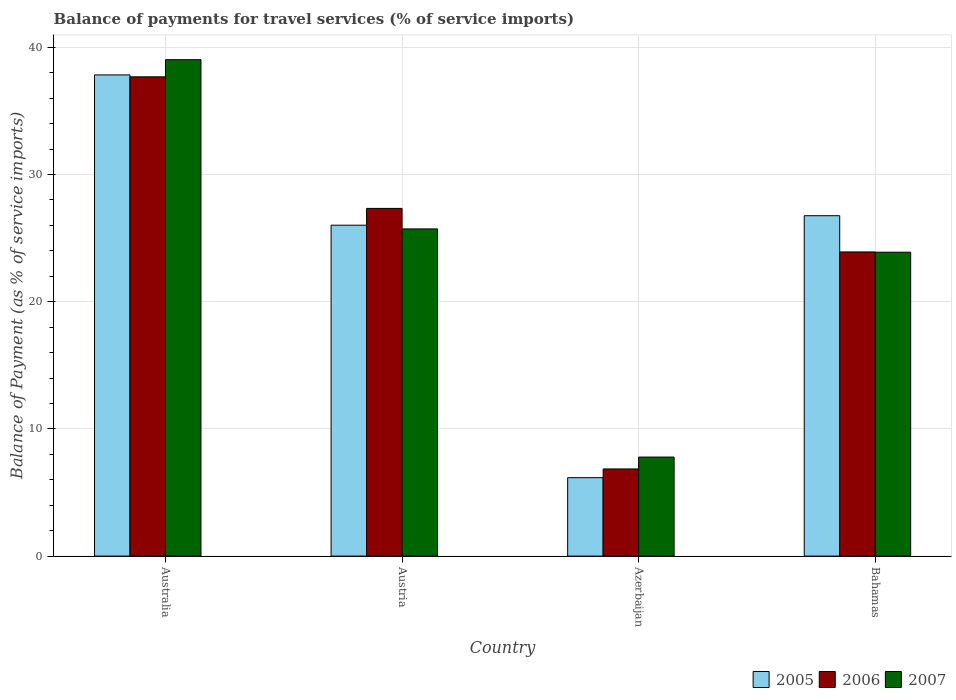How many different coloured bars are there?
Your answer should be compact. 3. How many groups of bars are there?
Offer a very short reply. 4. Are the number of bars per tick equal to the number of legend labels?
Your answer should be very brief. Yes. Are the number of bars on each tick of the X-axis equal?
Your answer should be very brief. Yes. How many bars are there on the 3rd tick from the left?
Provide a short and direct response. 3. What is the label of the 4th group of bars from the left?
Your answer should be compact. Bahamas. What is the balance of payments for travel services in 2006 in Bahamas?
Give a very brief answer. 23.92. Across all countries, what is the maximum balance of payments for travel services in 2007?
Make the answer very short. 39.03. Across all countries, what is the minimum balance of payments for travel services in 2007?
Your response must be concise. 7.79. In which country was the balance of payments for travel services in 2005 maximum?
Your answer should be compact. Australia. In which country was the balance of payments for travel services in 2005 minimum?
Offer a very short reply. Azerbaijan. What is the total balance of payments for travel services in 2007 in the graph?
Make the answer very short. 96.44. What is the difference between the balance of payments for travel services in 2006 in Australia and that in Bahamas?
Keep it short and to the point. 13.77. What is the difference between the balance of payments for travel services in 2007 in Austria and the balance of payments for travel services in 2005 in Bahamas?
Your response must be concise. -1.04. What is the average balance of payments for travel services in 2006 per country?
Ensure brevity in your answer.  23.95. What is the difference between the balance of payments for travel services of/in 2006 and balance of payments for travel services of/in 2007 in Australia?
Your response must be concise. -1.35. What is the ratio of the balance of payments for travel services in 2005 in Australia to that in Austria?
Offer a very short reply. 1.45. What is the difference between the highest and the second highest balance of payments for travel services in 2005?
Offer a very short reply. 0.75. What is the difference between the highest and the lowest balance of payments for travel services in 2005?
Your answer should be very brief. 31.67. In how many countries, is the balance of payments for travel services in 2006 greater than the average balance of payments for travel services in 2006 taken over all countries?
Give a very brief answer. 2. What does the 3rd bar from the left in Bahamas represents?
Offer a terse response. 2007. What does the 3rd bar from the right in Australia represents?
Keep it short and to the point. 2005. Is it the case that in every country, the sum of the balance of payments for travel services in 2007 and balance of payments for travel services in 2005 is greater than the balance of payments for travel services in 2006?
Your response must be concise. Yes. How many countries are there in the graph?
Offer a terse response. 4. Are the values on the major ticks of Y-axis written in scientific E-notation?
Make the answer very short. No. Does the graph contain any zero values?
Your answer should be compact. No. Where does the legend appear in the graph?
Your response must be concise. Bottom right. How many legend labels are there?
Your answer should be very brief. 3. How are the legend labels stacked?
Give a very brief answer. Horizontal. What is the title of the graph?
Give a very brief answer. Balance of payments for travel services (% of service imports). Does "2004" appear as one of the legend labels in the graph?
Offer a terse response. No. What is the label or title of the Y-axis?
Make the answer very short. Balance of Payment (as % of service imports). What is the Balance of Payment (as % of service imports) in 2005 in Australia?
Give a very brief answer. 37.83. What is the Balance of Payment (as % of service imports) in 2006 in Australia?
Offer a very short reply. 37.68. What is the Balance of Payment (as % of service imports) in 2007 in Australia?
Ensure brevity in your answer.  39.03. What is the Balance of Payment (as % of service imports) of 2005 in Austria?
Provide a short and direct response. 26.02. What is the Balance of Payment (as % of service imports) in 2006 in Austria?
Keep it short and to the point. 27.34. What is the Balance of Payment (as % of service imports) of 2007 in Austria?
Give a very brief answer. 25.73. What is the Balance of Payment (as % of service imports) in 2005 in Azerbaijan?
Provide a short and direct response. 6.17. What is the Balance of Payment (as % of service imports) in 2006 in Azerbaijan?
Keep it short and to the point. 6.85. What is the Balance of Payment (as % of service imports) of 2007 in Azerbaijan?
Make the answer very short. 7.79. What is the Balance of Payment (as % of service imports) of 2005 in Bahamas?
Your answer should be compact. 26.76. What is the Balance of Payment (as % of service imports) in 2006 in Bahamas?
Give a very brief answer. 23.92. What is the Balance of Payment (as % of service imports) in 2007 in Bahamas?
Offer a terse response. 23.89. Across all countries, what is the maximum Balance of Payment (as % of service imports) of 2005?
Make the answer very short. 37.83. Across all countries, what is the maximum Balance of Payment (as % of service imports) in 2006?
Give a very brief answer. 37.68. Across all countries, what is the maximum Balance of Payment (as % of service imports) in 2007?
Offer a terse response. 39.03. Across all countries, what is the minimum Balance of Payment (as % of service imports) in 2005?
Provide a short and direct response. 6.17. Across all countries, what is the minimum Balance of Payment (as % of service imports) of 2006?
Provide a succinct answer. 6.85. Across all countries, what is the minimum Balance of Payment (as % of service imports) of 2007?
Your answer should be compact. 7.79. What is the total Balance of Payment (as % of service imports) of 2005 in the graph?
Keep it short and to the point. 96.78. What is the total Balance of Payment (as % of service imports) of 2006 in the graph?
Make the answer very short. 95.79. What is the total Balance of Payment (as % of service imports) of 2007 in the graph?
Your answer should be very brief. 96.44. What is the difference between the Balance of Payment (as % of service imports) in 2005 in Australia and that in Austria?
Give a very brief answer. 11.82. What is the difference between the Balance of Payment (as % of service imports) of 2006 in Australia and that in Austria?
Provide a short and direct response. 10.34. What is the difference between the Balance of Payment (as % of service imports) of 2007 in Australia and that in Austria?
Keep it short and to the point. 13.31. What is the difference between the Balance of Payment (as % of service imports) of 2005 in Australia and that in Azerbaijan?
Provide a succinct answer. 31.67. What is the difference between the Balance of Payment (as % of service imports) in 2006 in Australia and that in Azerbaijan?
Your response must be concise. 30.83. What is the difference between the Balance of Payment (as % of service imports) of 2007 in Australia and that in Azerbaijan?
Keep it short and to the point. 31.24. What is the difference between the Balance of Payment (as % of service imports) of 2005 in Australia and that in Bahamas?
Give a very brief answer. 11.07. What is the difference between the Balance of Payment (as % of service imports) of 2006 in Australia and that in Bahamas?
Make the answer very short. 13.77. What is the difference between the Balance of Payment (as % of service imports) of 2007 in Australia and that in Bahamas?
Give a very brief answer. 15.14. What is the difference between the Balance of Payment (as % of service imports) in 2005 in Austria and that in Azerbaijan?
Your response must be concise. 19.85. What is the difference between the Balance of Payment (as % of service imports) in 2006 in Austria and that in Azerbaijan?
Provide a short and direct response. 20.49. What is the difference between the Balance of Payment (as % of service imports) in 2007 in Austria and that in Azerbaijan?
Offer a very short reply. 17.94. What is the difference between the Balance of Payment (as % of service imports) in 2005 in Austria and that in Bahamas?
Your answer should be compact. -0.75. What is the difference between the Balance of Payment (as % of service imports) of 2006 in Austria and that in Bahamas?
Offer a terse response. 3.42. What is the difference between the Balance of Payment (as % of service imports) in 2007 in Austria and that in Bahamas?
Offer a terse response. 1.83. What is the difference between the Balance of Payment (as % of service imports) of 2005 in Azerbaijan and that in Bahamas?
Your response must be concise. -20.6. What is the difference between the Balance of Payment (as % of service imports) of 2006 in Azerbaijan and that in Bahamas?
Give a very brief answer. -17.06. What is the difference between the Balance of Payment (as % of service imports) in 2007 in Azerbaijan and that in Bahamas?
Give a very brief answer. -16.11. What is the difference between the Balance of Payment (as % of service imports) of 2005 in Australia and the Balance of Payment (as % of service imports) of 2006 in Austria?
Your answer should be compact. 10.49. What is the difference between the Balance of Payment (as % of service imports) in 2005 in Australia and the Balance of Payment (as % of service imports) in 2007 in Austria?
Offer a very short reply. 12.11. What is the difference between the Balance of Payment (as % of service imports) in 2006 in Australia and the Balance of Payment (as % of service imports) in 2007 in Austria?
Ensure brevity in your answer.  11.96. What is the difference between the Balance of Payment (as % of service imports) of 2005 in Australia and the Balance of Payment (as % of service imports) of 2006 in Azerbaijan?
Your answer should be very brief. 30.98. What is the difference between the Balance of Payment (as % of service imports) of 2005 in Australia and the Balance of Payment (as % of service imports) of 2007 in Azerbaijan?
Make the answer very short. 30.05. What is the difference between the Balance of Payment (as % of service imports) of 2006 in Australia and the Balance of Payment (as % of service imports) of 2007 in Azerbaijan?
Offer a terse response. 29.9. What is the difference between the Balance of Payment (as % of service imports) in 2005 in Australia and the Balance of Payment (as % of service imports) in 2006 in Bahamas?
Offer a terse response. 13.92. What is the difference between the Balance of Payment (as % of service imports) in 2005 in Australia and the Balance of Payment (as % of service imports) in 2007 in Bahamas?
Your answer should be very brief. 13.94. What is the difference between the Balance of Payment (as % of service imports) of 2006 in Australia and the Balance of Payment (as % of service imports) of 2007 in Bahamas?
Ensure brevity in your answer.  13.79. What is the difference between the Balance of Payment (as % of service imports) in 2005 in Austria and the Balance of Payment (as % of service imports) in 2006 in Azerbaijan?
Keep it short and to the point. 19.17. What is the difference between the Balance of Payment (as % of service imports) of 2005 in Austria and the Balance of Payment (as % of service imports) of 2007 in Azerbaijan?
Your answer should be compact. 18.23. What is the difference between the Balance of Payment (as % of service imports) in 2006 in Austria and the Balance of Payment (as % of service imports) in 2007 in Azerbaijan?
Make the answer very short. 19.55. What is the difference between the Balance of Payment (as % of service imports) in 2005 in Austria and the Balance of Payment (as % of service imports) in 2006 in Bahamas?
Your answer should be compact. 2.1. What is the difference between the Balance of Payment (as % of service imports) in 2005 in Austria and the Balance of Payment (as % of service imports) in 2007 in Bahamas?
Make the answer very short. 2.12. What is the difference between the Balance of Payment (as % of service imports) in 2006 in Austria and the Balance of Payment (as % of service imports) in 2007 in Bahamas?
Ensure brevity in your answer.  3.44. What is the difference between the Balance of Payment (as % of service imports) in 2005 in Azerbaijan and the Balance of Payment (as % of service imports) in 2006 in Bahamas?
Your answer should be compact. -17.75. What is the difference between the Balance of Payment (as % of service imports) of 2005 in Azerbaijan and the Balance of Payment (as % of service imports) of 2007 in Bahamas?
Your response must be concise. -17.73. What is the difference between the Balance of Payment (as % of service imports) of 2006 in Azerbaijan and the Balance of Payment (as % of service imports) of 2007 in Bahamas?
Your answer should be very brief. -17.04. What is the average Balance of Payment (as % of service imports) in 2005 per country?
Your answer should be compact. 24.2. What is the average Balance of Payment (as % of service imports) in 2006 per country?
Ensure brevity in your answer.  23.95. What is the average Balance of Payment (as % of service imports) in 2007 per country?
Ensure brevity in your answer.  24.11. What is the difference between the Balance of Payment (as % of service imports) of 2005 and Balance of Payment (as % of service imports) of 2006 in Australia?
Your answer should be very brief. 0.15. What is the difference between the Balance of Payment (as % of service imports) in 2005 and Balance of Payment (as % of service imports) in 2007 in Australia?
Keep it short and to the point. -1.2. What is the difference between the Balance of Payment (as % of service imports) of 2006 and Balance of Payment (as % of service imports) of 2007 in Australia?
Make the answer very short. -1.35. What is the difference between the Balance of Payment (as % of service imports) in 2005 and Balance of Payment (as % of service imports) in 2006 in Austria?
Provide a succinct answer. -1.32. What is the difference between the Balance of Payment (as % of service imports) in 2005 and Balance of Payment (as % of service imports) in 2007 in Austria?
Your answer should be compact. 0.29. What is the difference between the Balance of Payment (as % of service imports) in 2006 and Balance of Payment (as % of service imports) in 2007 in Austria?
Give a very brief answer. 1.61. What is the difference between the Balance of Payment (as % of service imports) of 2005 and Balance of Payment (as % of service imports) of 2006 in Azerbaijan?
Ensure brevity in your answer.  -0.69. What is the difference between the Balance of Payment (as % of service imports) of 2005 and Balance of Payment (as % of service imports) of 2007 in Azerbaijan?
Your answer should be very brief. -1.62. What is the difference between the Balance of Payment (as % of service imports) in 2006 and Balance of Payment (as % of service imports) in 2007 in Azerbaijan?
Provide a succinct answer. -0.93. What is the difference between the Balance of Payment (as % of service imports) in 2005 and Balance of Payment (as % of service imports) in 2006 in Bahamas?
Keep it short and to the point. 2.85. What is the difference between the Balance of Payment (as % of service imports) in 2005 and Balance of Payment (as % of service imports) in 2007 in Bahamas?
Your response must be concise. 2.87. What is the difference between the Balance of Payment (as % of service imports) in 2006 and Balance of Payment (as % of service imports) in 2007 in Bahamas?
Make the answer very short. 0.02. What is the ratio of the Balance of Payment (as % of service imports) of 2005 in Australia to that in Austria?
Offer a terse response. 1.45. What is the ratio of the Balance of Payment (as % of service imports) in 2006 in Australia to that in Austria?
Offer a terse response. 1.38. What is the ratio of the Balance of Payment (as % of service imports) in 2007 in Australia to that in Austria?
Your answer should be compact. 1.52. What is the ratio of the Balance of Payment (as % of service imports) of 2005 in Australia to that in Azerbaijan?
Offer a very short reply. 6.14. What is the ratio of the Balance of Payment (as % of service imports) of 2006 in Australia to that in Azerbaijan?
Give a very brief answer. 5.5. What is the ratio of the Balance of Payment (as % of service imports) in 2007 in Australia to that in Azerbaijan?
Ensure brevity in your answer.  5.01. What is the ratio of the Balance of Payment (as % of service imports) in 2005 in Australia to that in Bahamas?
Offer a terse response. 1.41. What is the ratio of the Balance of Payment (as % of service imports) of 2006 in Australia to that in Bahamas?
Give a very brief answer. 1.58. What is the ratio of the Balance of Payment (as % of service imports) of 2007 in Australia to that in Bahamas?
Offer a very short reply. 1.63. What is the ratio of the Balance of Payment (as % of service imports) of 2005 in Austria to that in Azerbaijan?
Offer a terse response. 4.22. What is the ratio of the Balance of Payment (as % of service imports) in 2006 in Austria to that in Azerbaijan?
Offer a terse response. 3.99. What is the ratio of the Balance of Payment (as % of service imports) of 2007 in Austria to that in Azerbaijan?
Your answer should be very brief. 3.3. What is the ratio of the Balance of Payment (as % of service imports) of 2005 in Austria to that in Bahamas?
Make the answer very short. 0.97. What is the ratio of the Balance of Payment (as % of service imports) of 2006 in Austria to that in Bahamas?
Your answer should be compact. 1.14. What is the ratio of the Balance of Payment (as % of service imports) of 2007 in Austria to that in Bahamas?
Make the answer very short. 1.08. What is the ratio of the Balance of Payment (as % of service imports) in 2005 in Azerbaijan to that in Bahamas?
Your answer should be compact. 0.23. What is the ratio of the Balance of Payment (as % of service imports) in 2006 in Azerbaijan to that in Bahamas?
Offer a terse response. 0.29. What is the ratio of the Balance of Payment (as % of service imports) of 2007 in Azerbaijan to that in Bahamas?
Offer a terse response. 0.33. What is the difference between the highest and the second highest Balance of Payment (as % of service imports) in 2005?
Your answer should be very brief. 11.07. What is the difference between the highest and the second highest Balance of Payment (as % of service imports) in 2006?
Your response must be concise. 10.34. What is the difference between the highest and the second highest Balance of Payment (as % of service imports) in 2007?
Give a very brief answer. 13.31. What is the difference between the highest and the lowest Balance of Payment (as % of service imports) in 2005?
Keep it short and to the point. 31.67. What is the difference between the highest and the lowest Balance of Payment (as % of service imports) in 2006?
Offer a very short reply. 30.83. What is the difference between the highest and the lowest Balance of Payment (as % of service imports) of 2007?
Your answer should be very brief. 31.24. 